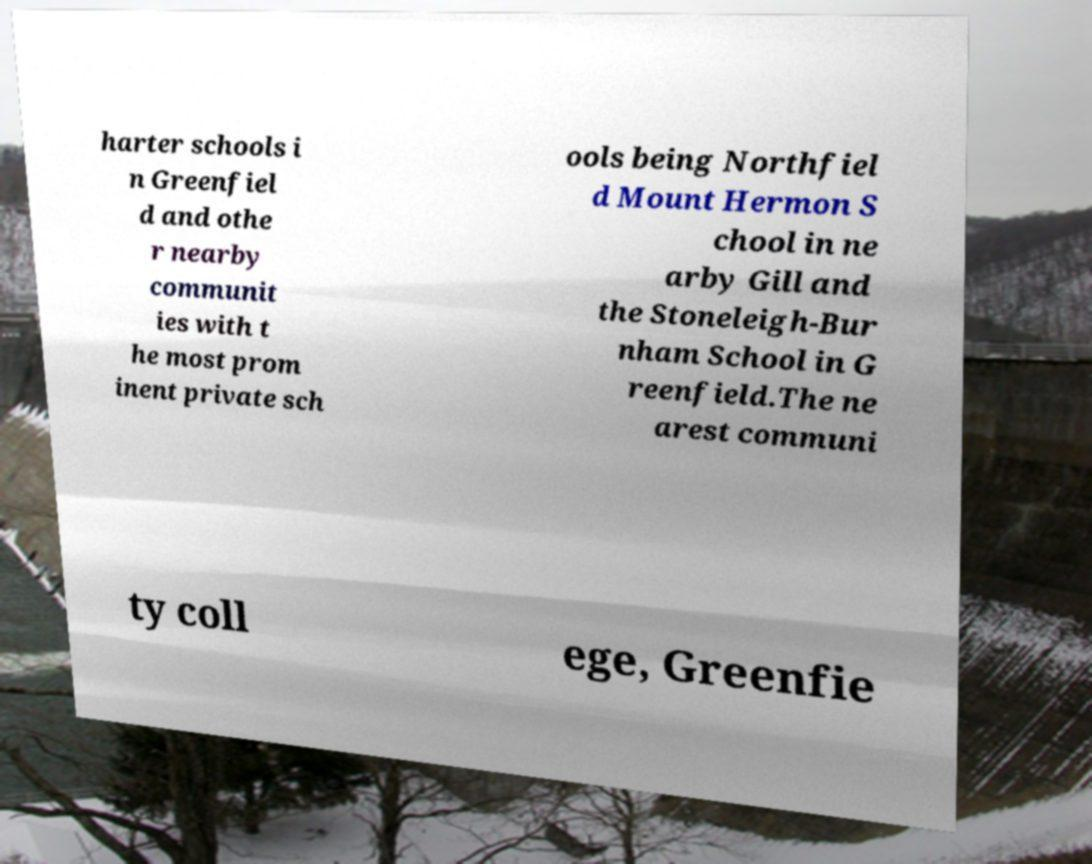Can you accurately transcribe the text from the provided image for me? harter schools i n Greenfiel d and othe r nearby communit ies with t he most prom inent private sch ools being Northfiel d Mount Hermon S chool in ne arby Gill and the Stoneleigh-Bur nham School in G reenfield.The ne arest communi ty coll ege, Greenfie 